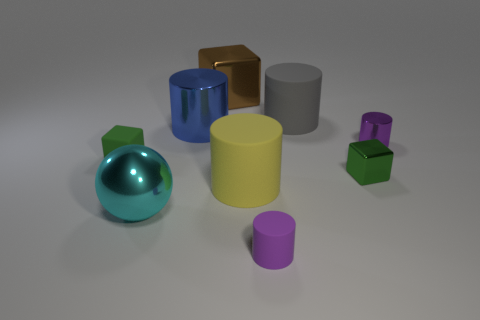How many green things are cubes or cylinders?
Your answer should be compact. 2. What number of other rubber cylinders are the same size as the yellow cylinder?
Provide a short and direct response. 1. There is a object that is in front of the green metal block and left of the blue thing; what color is it?
Provide a succinct answer. Cyan. Are there more matte cubes behind the tiny rubber block than tiny gray rubber spheres?
Your answer should be very brief. No. Are any green shiny things visible?
Your answer should be very brief. Yes. Do the small metallic block and the tiny matte block have the same color?
Provide a short and direct response. Yes. What number of tiny things are purple metallic cubes or green metal cubes?
Make the answer very short. 1. Are there any other things that are the same color as the big ball?
Provide a succinct answer. No. There is a big blue thing that is the same material as the large cyan thing; what shape is it?
Keep it short and to the point. Cylinder. What is the size of the shiny cube that is behind the purple metal object?
Keep it short and to the point. Large. 